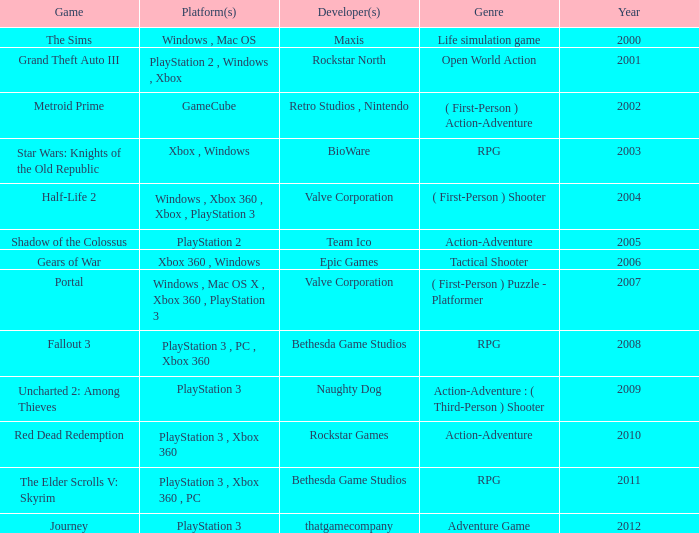What game was in 2001? Grand Theft Auto III. 